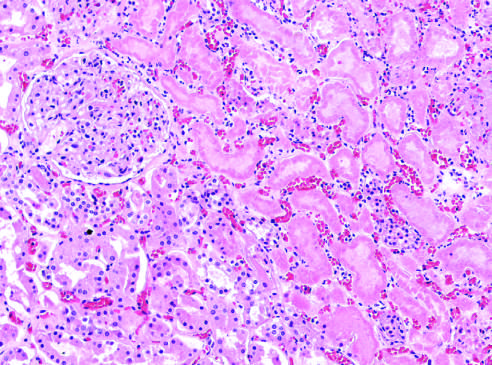do skin stem cells show preserved outlines with loss of nuclei?
Answer the question using a single word or phrase. No 